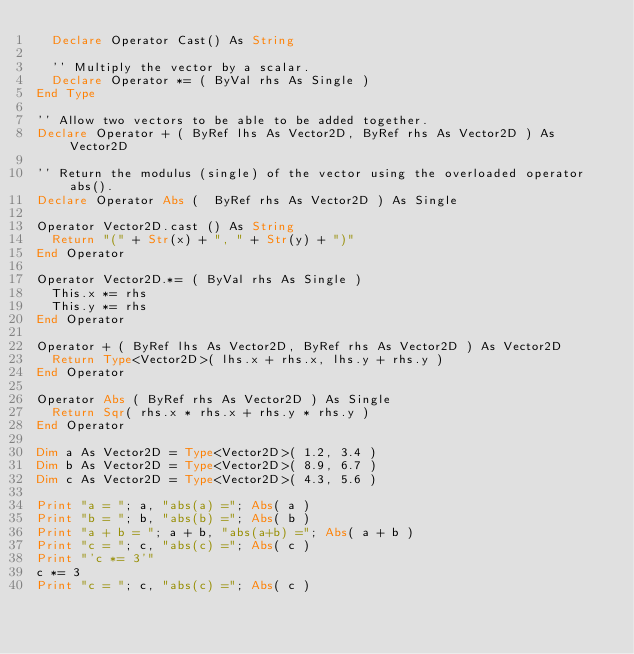Convert code to text. <code><loc_0><loc_0><loc_500><loc_500><_VisualBasic_>  Declare Operator Cast() As String

  '' Multiply the vector by a scalar.
  Declare Operator *= ( ByVal rhs As Single )
End Type

'' Allow two vectors to be able to be added together.
Declare Operator + ( ByRef lhs As Vector2D, ByRef rhs As Vector2D ) As Vector2D

'' Return the modulus (single) of the vector using the overloaded operator abs().
Declare Operator Abs (  ByRef rhs As Vector2D ) As Single

Operator Vector2D.cast () As String
  Return "(" + Str(x) + ", " + Str(y) + ")"
End Operator

Operator Vector2D.*= ( ByVal rhs As Single )
  This.x *= rhs
  This.y *= rhs
End Operator

Operator + ( ByRef lhs As Vector2D, ByRef rhs As Vector2D ) As Vector2D
  Return Type<Vector2D>( lhs.x + rhs.x, lhs.y + rhs.y )
End Operator

Operator Abs ( ByRef rhs As Vector2D ) As Single
  Return Sqr( rhs.x * rhs.x + rhs.y * rhs.y )
End Operator

Dim a As Vector2D = Type<Vector2D>( 1.2, 3.4 )
Dim b As Vector2D = Type<Vector2D>( 8.9, 6.7 )
Dim c As Vector2D = Type<Vector2D>( 4.3, 5.6 )

Print "a = "; a, "abs(a) ="; Abs( a )
Print "b = "; b, "abs(b) ="; Abs( b )
Print "a + b = "; a + b, "abs(a+b) ="; Abs( a + b )
Print "c = "; c, "abs(c) ="; Abs( c )
Print "'c *= 3'"
c *= 3
Print "c = "; c, "abs(c) ="; Abs( c )
</code> 